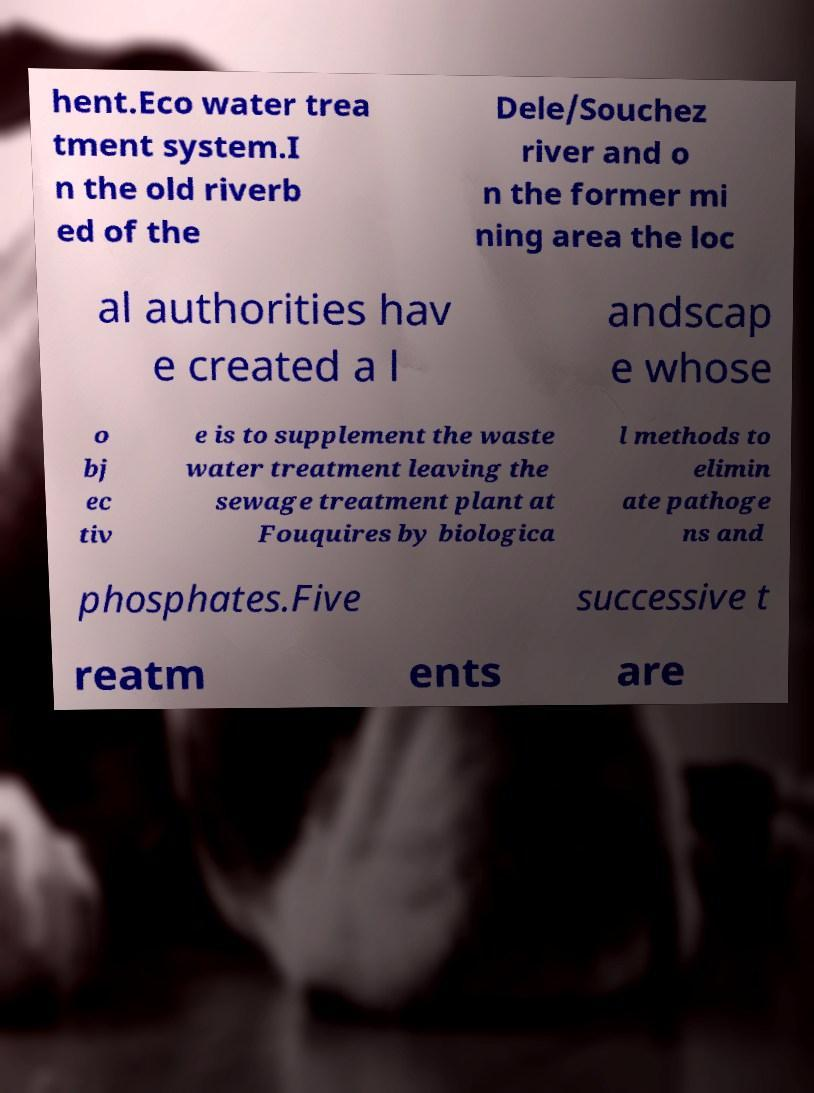There's text embedded in this image that I need extracted. Can you transcribe it verbatim? hent.Eco water trea tment system.I n the old riverb ed of the Dele/Souchez river and o n the former mi ning area the loc al authorities hav e created a l andscap e whose o bj ec tiv e is to supplement the waste water treatment leaving the sewage treatment plant at Fouquires by biologica l methods to elimin ate pathoge ns and phosphates.Five successive t reatm ents are 